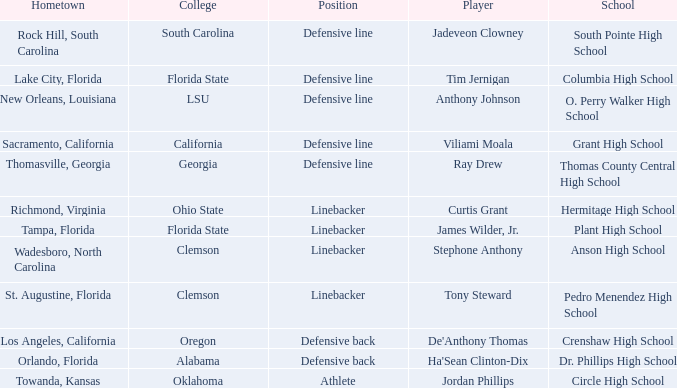Which hometown has a player of Ray Drew? Thomasville, Georgia. 